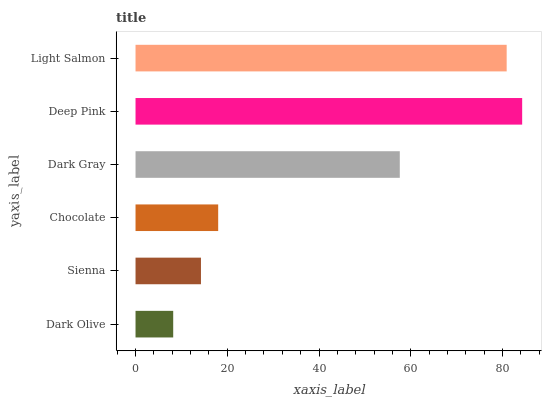Is Dark Olive the minimum?
Answer yes or no. Yes. Is Deep Pink the maximum?
Answer yes or no. Yes. Is Sienna the minimum?
Answer yes or no. No. Is Sienna the maximum?
Answer yes or no. No. Is Sienna greater than Dark Olive?
Answer yes or no. Yes. Is Dark Olive less than Sienna?
Answer yes or no. Yes. Is Dark Olive greater than Sienna?
Answer yes or no. No. Is Sienna less than Dark Olive?
Answer yes or no. No. Is Dark Gray the high median?
Answer yes or no. Yes. Is Chocolate the low median?
Answer yes or no. Yes. Is Deep Pink the high median?
Answer yes or no. No. Is Dark Gray the low median?
Answer yes or no. No. 